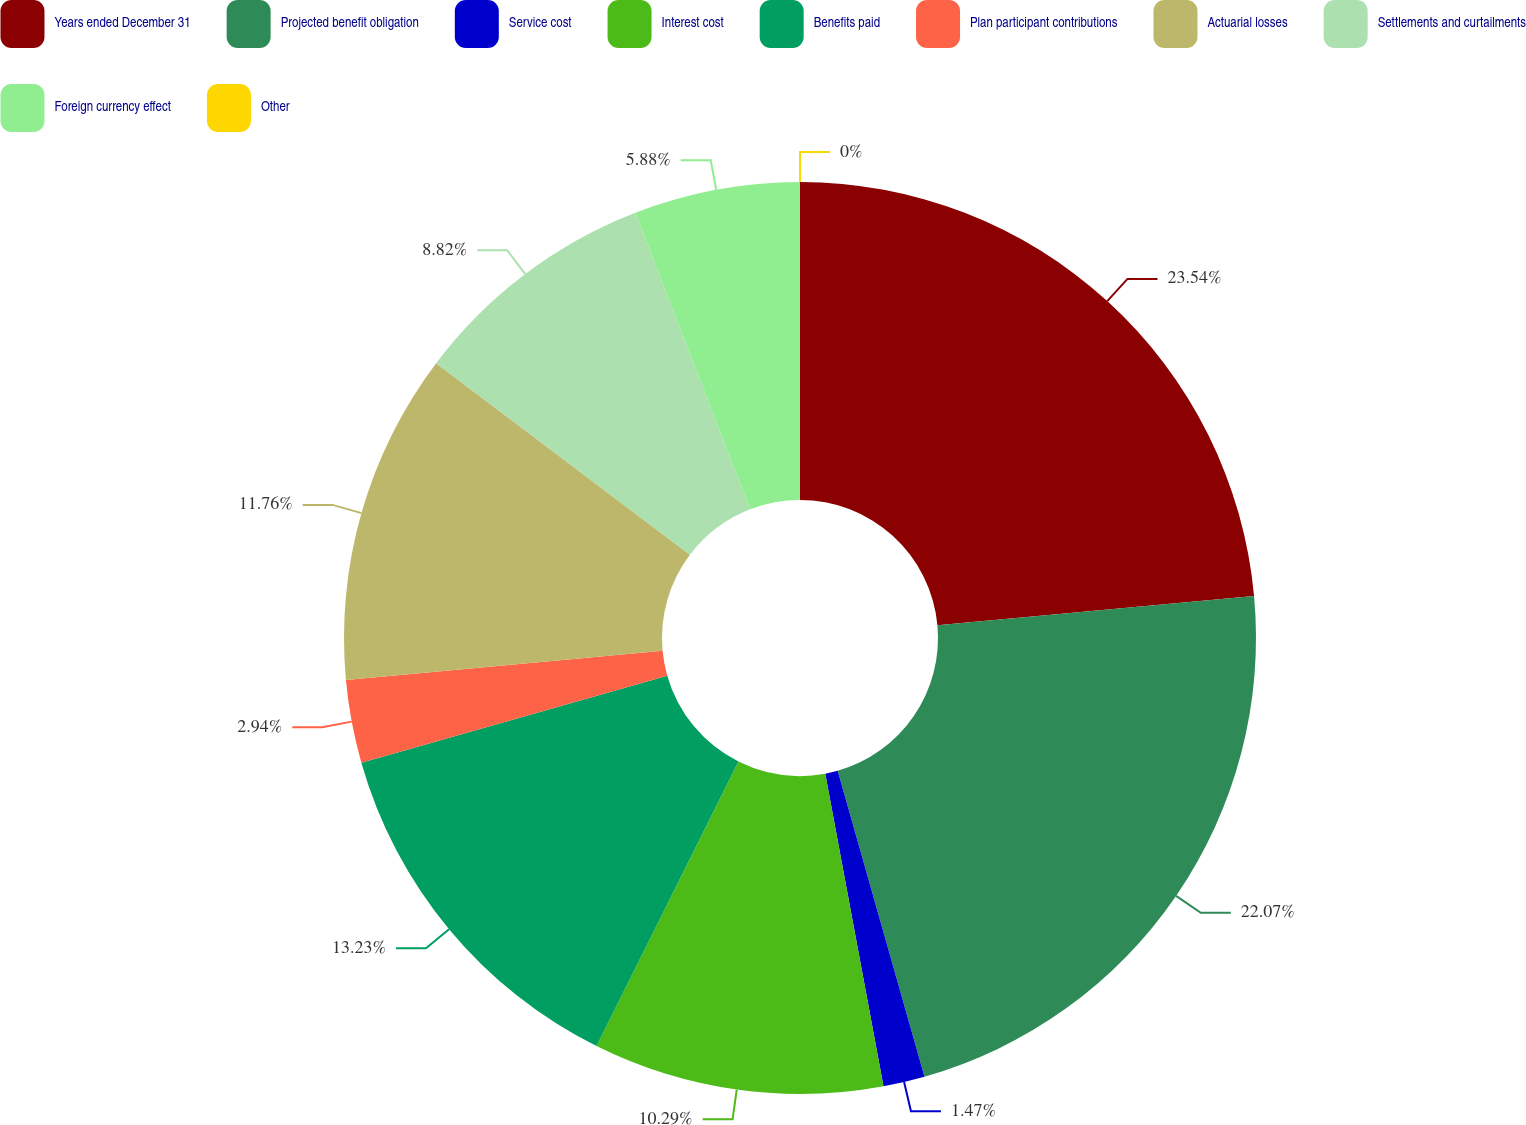Convert chart. <chart><loc_0><loc_0><loc_500><loc_500><pie_chart><fcel>Years ended December 31<fcel>Projected benefit obligation<fcel>Service cost<fcel>Interest cost<fcel>Benefits paid<fcel>Plan participant contributions<fcel>Actuarial losses<fcel>Settlements and curtailments<fcel>Foreign currency effect<fcel>Other<nl><fcel>23.53%<fcel>22.06%<fcel>1.47%<fcel>10.29%<fcel>13.23%<fcel>2.94%<fcel>11.76%<fcel>8.82%<fcel>5.88%<fcel>0.0%<nl></chart> 